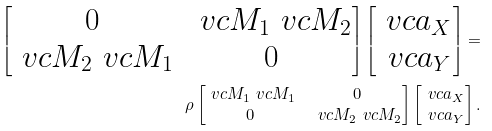<formula> <loc_0><loc_0><loc_500><loc_500>\begin{bmatrix} 0 & \ v c { M } _ { 1 } \ v c { M } _ { 2 } \\ \ v c { M } _ { 2 } \ v c { M } _ { 1 } & 0 \\ \end{bmatrix} \begin{bmatrix} \ v c { a } _ { X } \\ \ v c { a } _ { Y } \\ \end{bmatrix} = & \\ \rho \begin{bmatrix} \ v c { M } _ { 1 } \ v c { M } _ { 1 } & 0 \\ 0 & \ v c { M } _ { 2 } \ v c { M } _ { 2 } \\ \end{bmatrix} \begin{bmatrix} \ v c { a } _ { X } \\ \ v c { a } _ { Y } \\ \end{bmatrix} .</formula> 